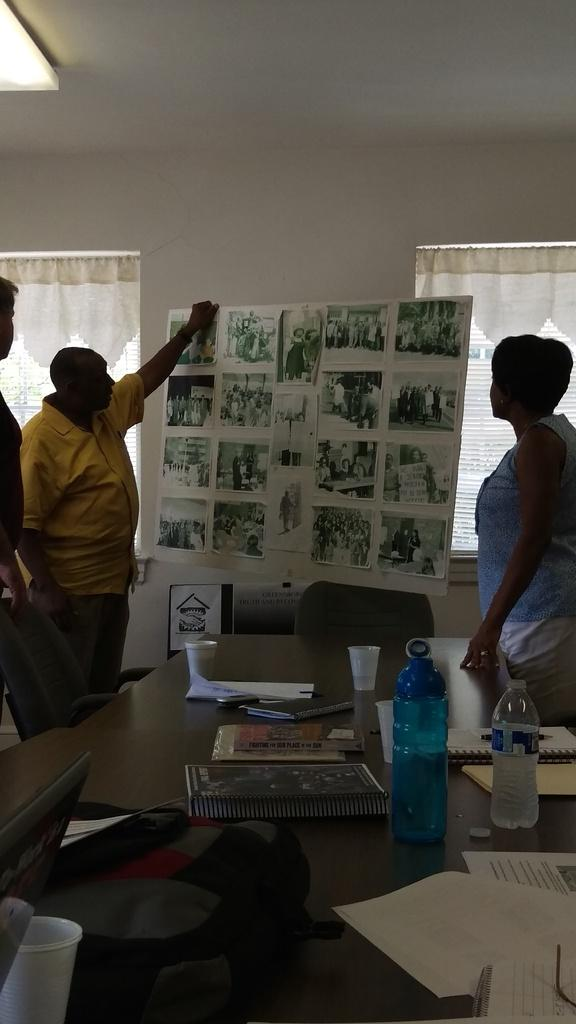How many people are in the image? There are three people standing next to a table in the image. What furniture is visible in the image? Chairs are visible in the image. What items are on the table? There are bottles, papers, and a laptop on the table. What type of pipe is being used for education in the image? There is no pipe or reference to education present in the image. Is there any milk visible in the image? There is no milk visible in the image. 